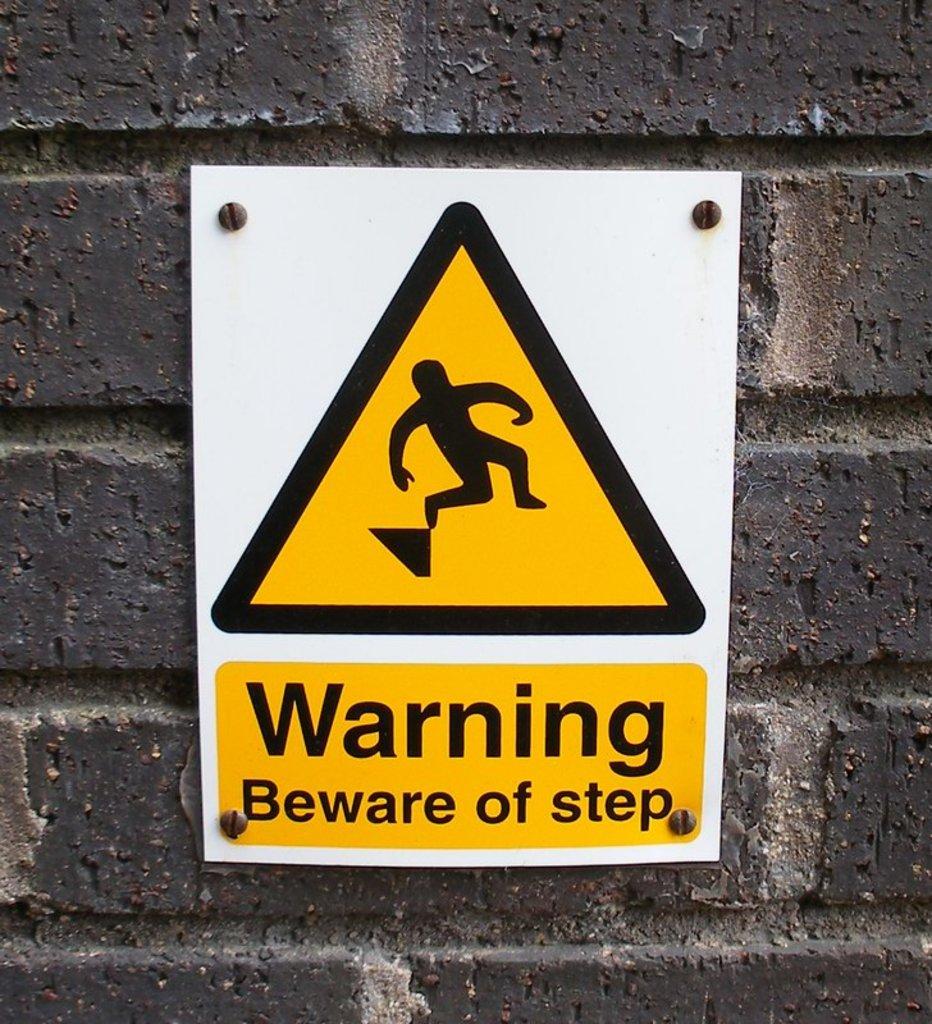What should you beware of?
Offer a very short reply. Step. How many screws hold the sign up?
Provide a short and direct response. 4. 